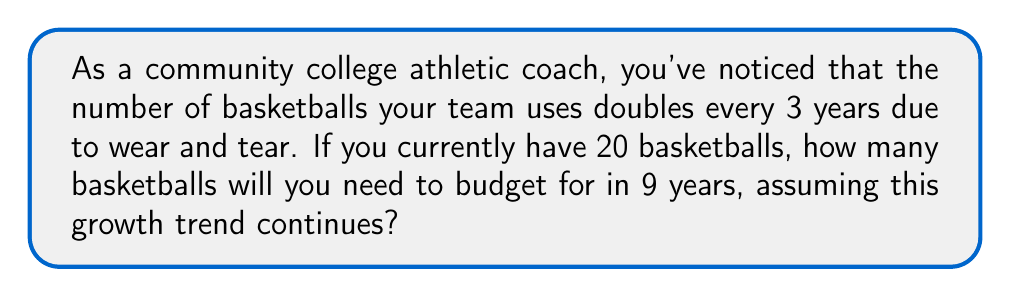Can you answer this question? Let's approach this step-by-step using an exponential growth function:

1) The general form of an exponential growth function is:
   $$ A(t) = A_0 \cdot (1 + r)^t $$
   where $A_0$ is the initial amount, $r$ is the growth rate, and $t$ is the time.

2) In this case:
   $A_0 = 20$ (initial number of basketballs)
   The number doubles every 3 years, so in 3 years, we have:
   $$ 20 \cdot (1 + r)^3 = 40 $$

3) Solve for $r$:
   $$ (1 + r)^3 = 2 $$
   $$ 1 + r = 2^{\frac{1}{3}} $$
   $$ r = 2^{\frac{1}{3}} - 1 \approx 0.2599 \text{ or about } 26\% $$

4) Now we can use the exponential growth function for 9 years:
   $$ A(9) = 20 \cdot (1 + 0.2599)^9 $$

5) Calculate:
   $$ A(9) = 20 \cdot (1.2599)^9 \approx 160.00 $$

6) Since we can't have a fraction of a basketball, we round up to the nearest whole number.
Answer: 161 basketballs 